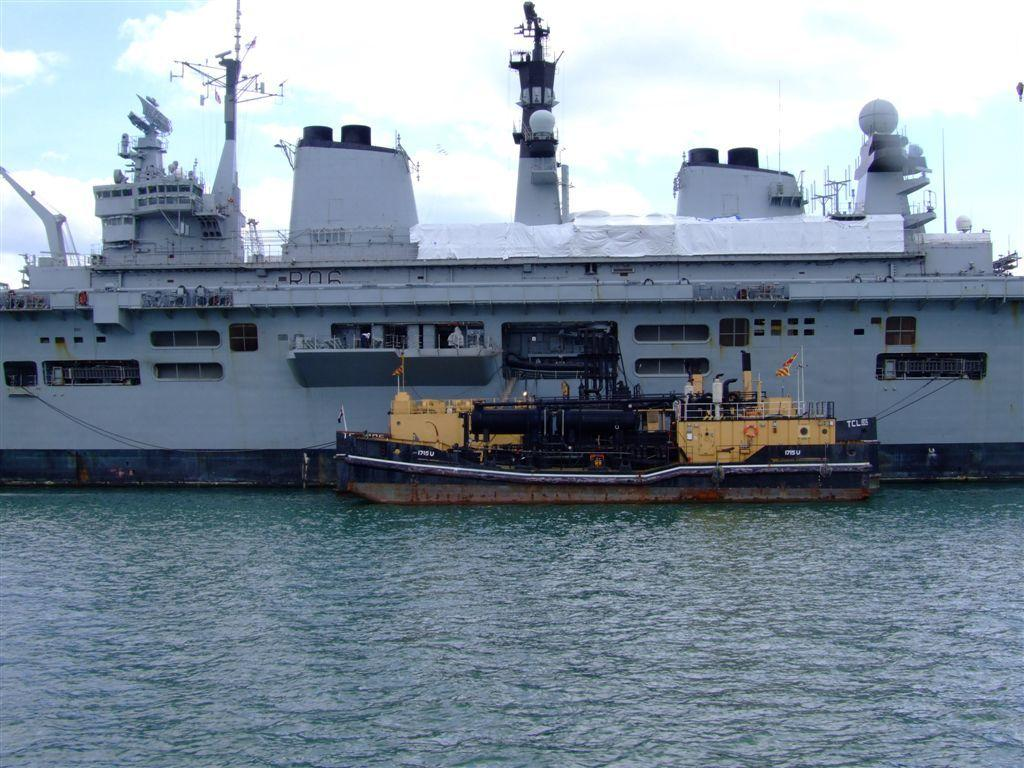What type of vehicles can be seen above the water in the image? There are ships visible above the water in the image. What is the condition of the sky in the background of the image? The sky is cloudy in the background of the image. What type of knot is being used to tie the ships together in the image? There is no indication in the image that the ships are tied together, nor is there any visible knot. What type of glass object is present on the ships in the image? There is no glass object present on the ships in the image. 